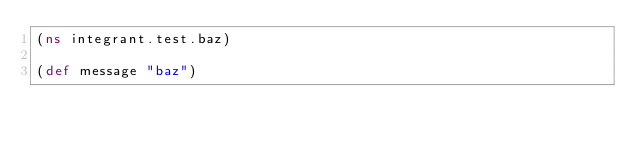Convert code to text. <code><loc_0><loc_0><loc_500><loc_500><_Clojure_>(ns integrant.test.baz)

(def message "baz")
</code> 